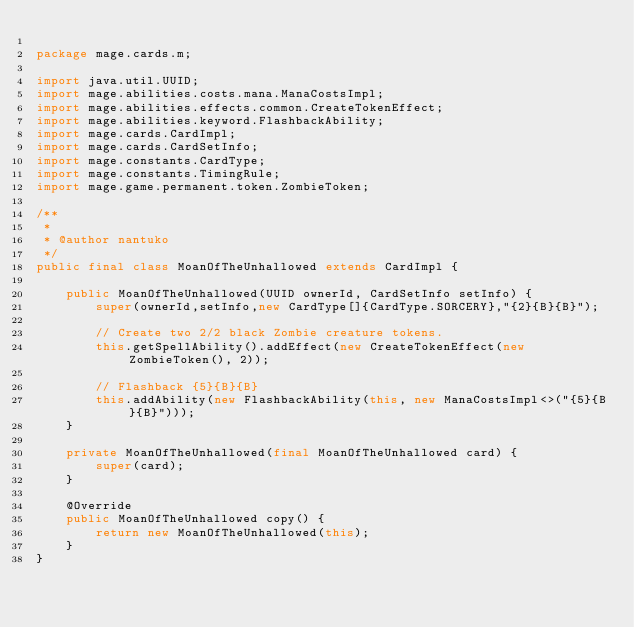<code> <loc_0><loc_0><loc_500><loc_500><_Java_>
package mage.cards.m;

import java.util.UUID;
import mage.abilities.costs.mana.ManaCostsImpl;
import mage.abilities.effects.common.CreateTokenEffect;
import mage.abilities.keyword.FlashbackAbility;
import mage.cards.CardImpl;
import mage.cards.CardSetInfo;
import mage.constants.CardType;
import mage.constants.TimingRule;
import mage.game.permanent.token.ZombieToken;

/**
 *
 * @author nantuko
 */
public final class MoanOfTheUnhallowed extends CardImpl {

    public MoanOfTheUnhallowed(UUID ownerId, CardSetInfo setInfo) {
        super(ownerId,setInfo,new CardType[]{CardType.SORCERY},"{2}{B}{B}");

        // Create two 2/2 black Zombie creature tokens.
        this.getSpellAbility().addEffect(new CreateTokenEffect(new ZombieToken(), 2));

        // Flashback {5}{B}{B}
        this.addAbility(new FlashbackAbility(this, new ManaCostsImpl<>("{5}{B}{B}")));
    }

    private MoanOfTheUnhallowed(final MoanOfTheUnhallowed card) {
        super(card);
    }

    @Override
    public MoanOfTheUnhallowed copy() {
        return new MoanOfTheUnhallowed(this);
    }
}
</code> 